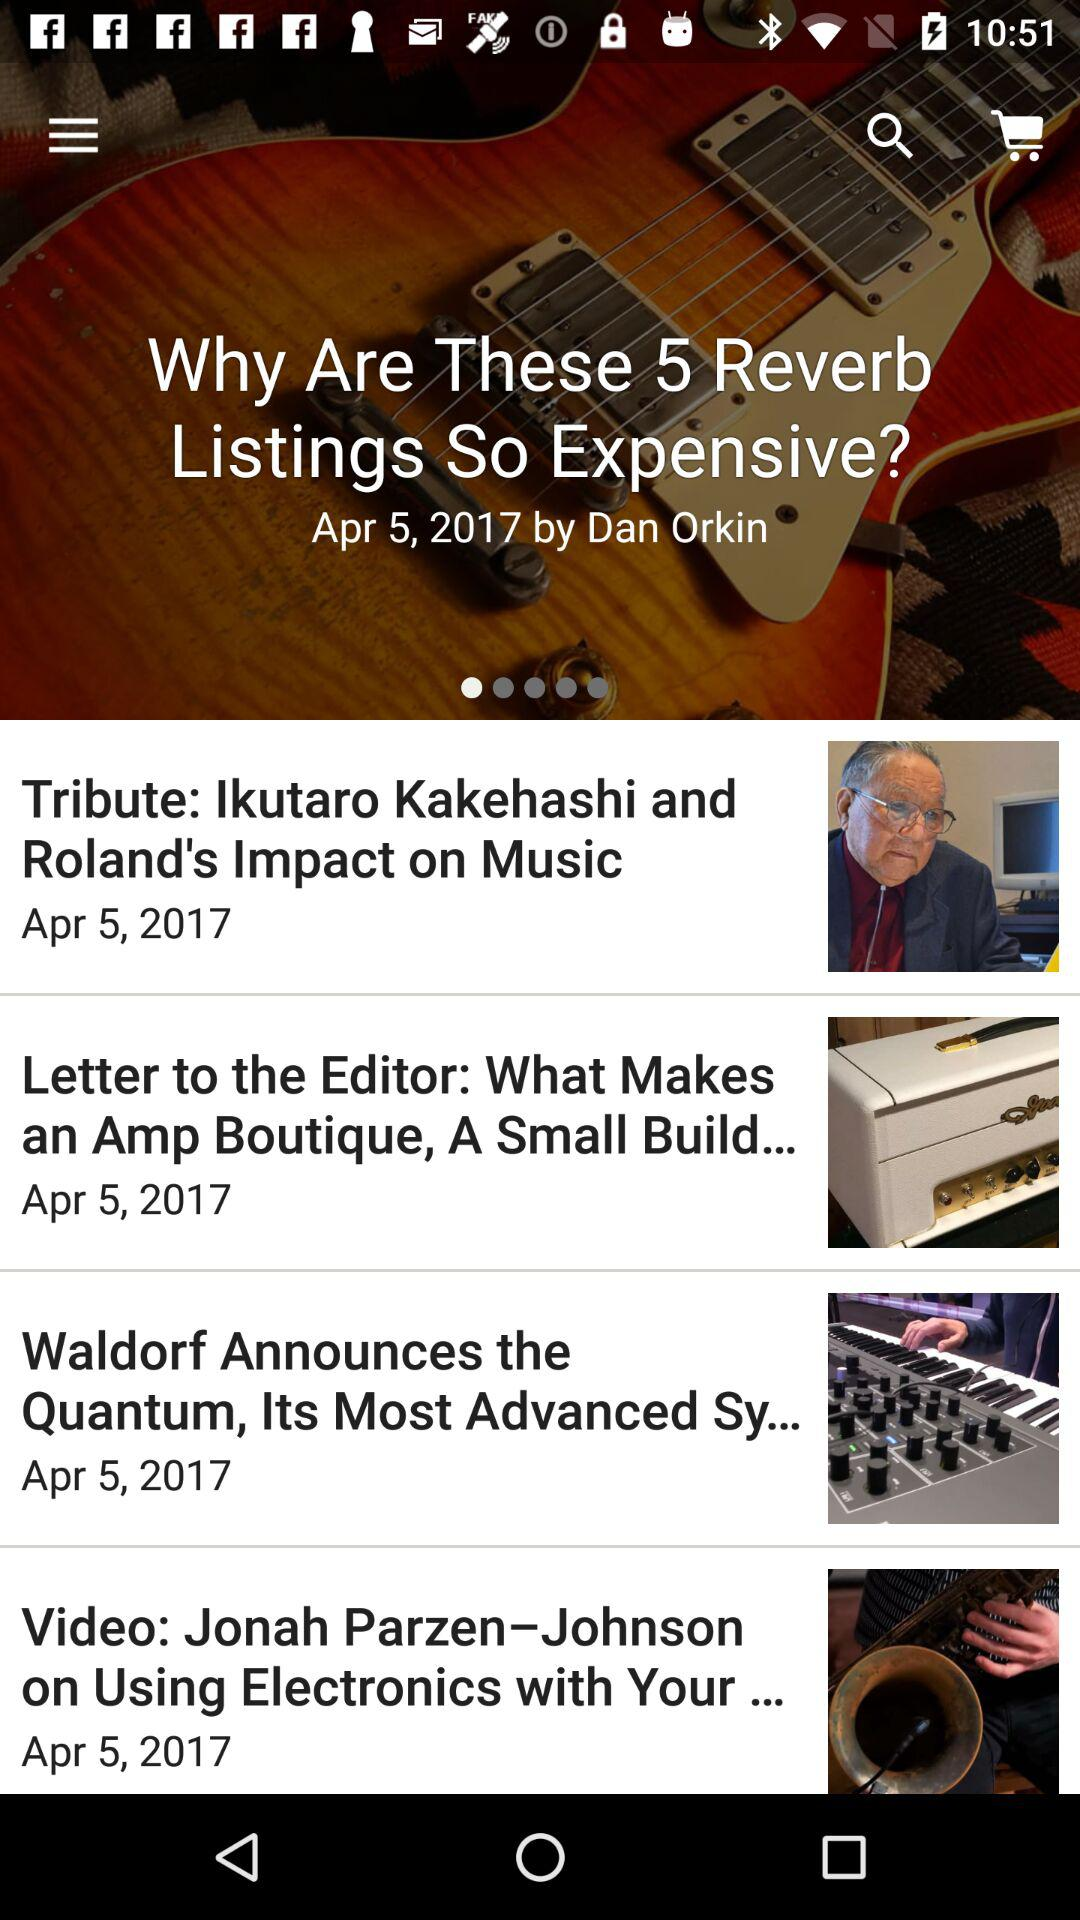What is the headline of the article? The headline of the article is "Why Are These 5 Reverb Listings So Expensive?". 